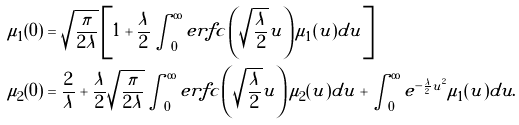<formula> <loc_0><loc_0><loc_500><loc_500>\mu _ { 1 } ( 0 ) & = \sqrt { \frac { \pi } { 2 \lambda } } \left [ 1 + \frac { \lambda } { 2 } \int _ { 0 } ^ { \infty } e r f c \left ( \sqrt { \frac { \lambda } { 2 } } u \right ) \mu _ { 1 } ( u ) d u \right ] \\ \mu _ { 2 } ( 0 ) & = \frac { 2 } { \lambda } + \frac { \lambda } { 2 } \sqrt { \frac { \pi } { 2 \lambda } } \int _ { 0 } ^ { \infty } e r f c \left ( \sqrt { \frac { \lambda } { 2 } } u \right ) \mu _ { 2 } ( u ) d u + \int _ { 0 } ^ { \infty } e ^ { - \frac { \lambda } { 2 } u ^ { 2 } } \mu _ { 1 } ( u ) d u .</formula> 